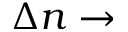<formula> <loc_0><loc_0><loc_500><loc_500>\Delta n \to</formula> 